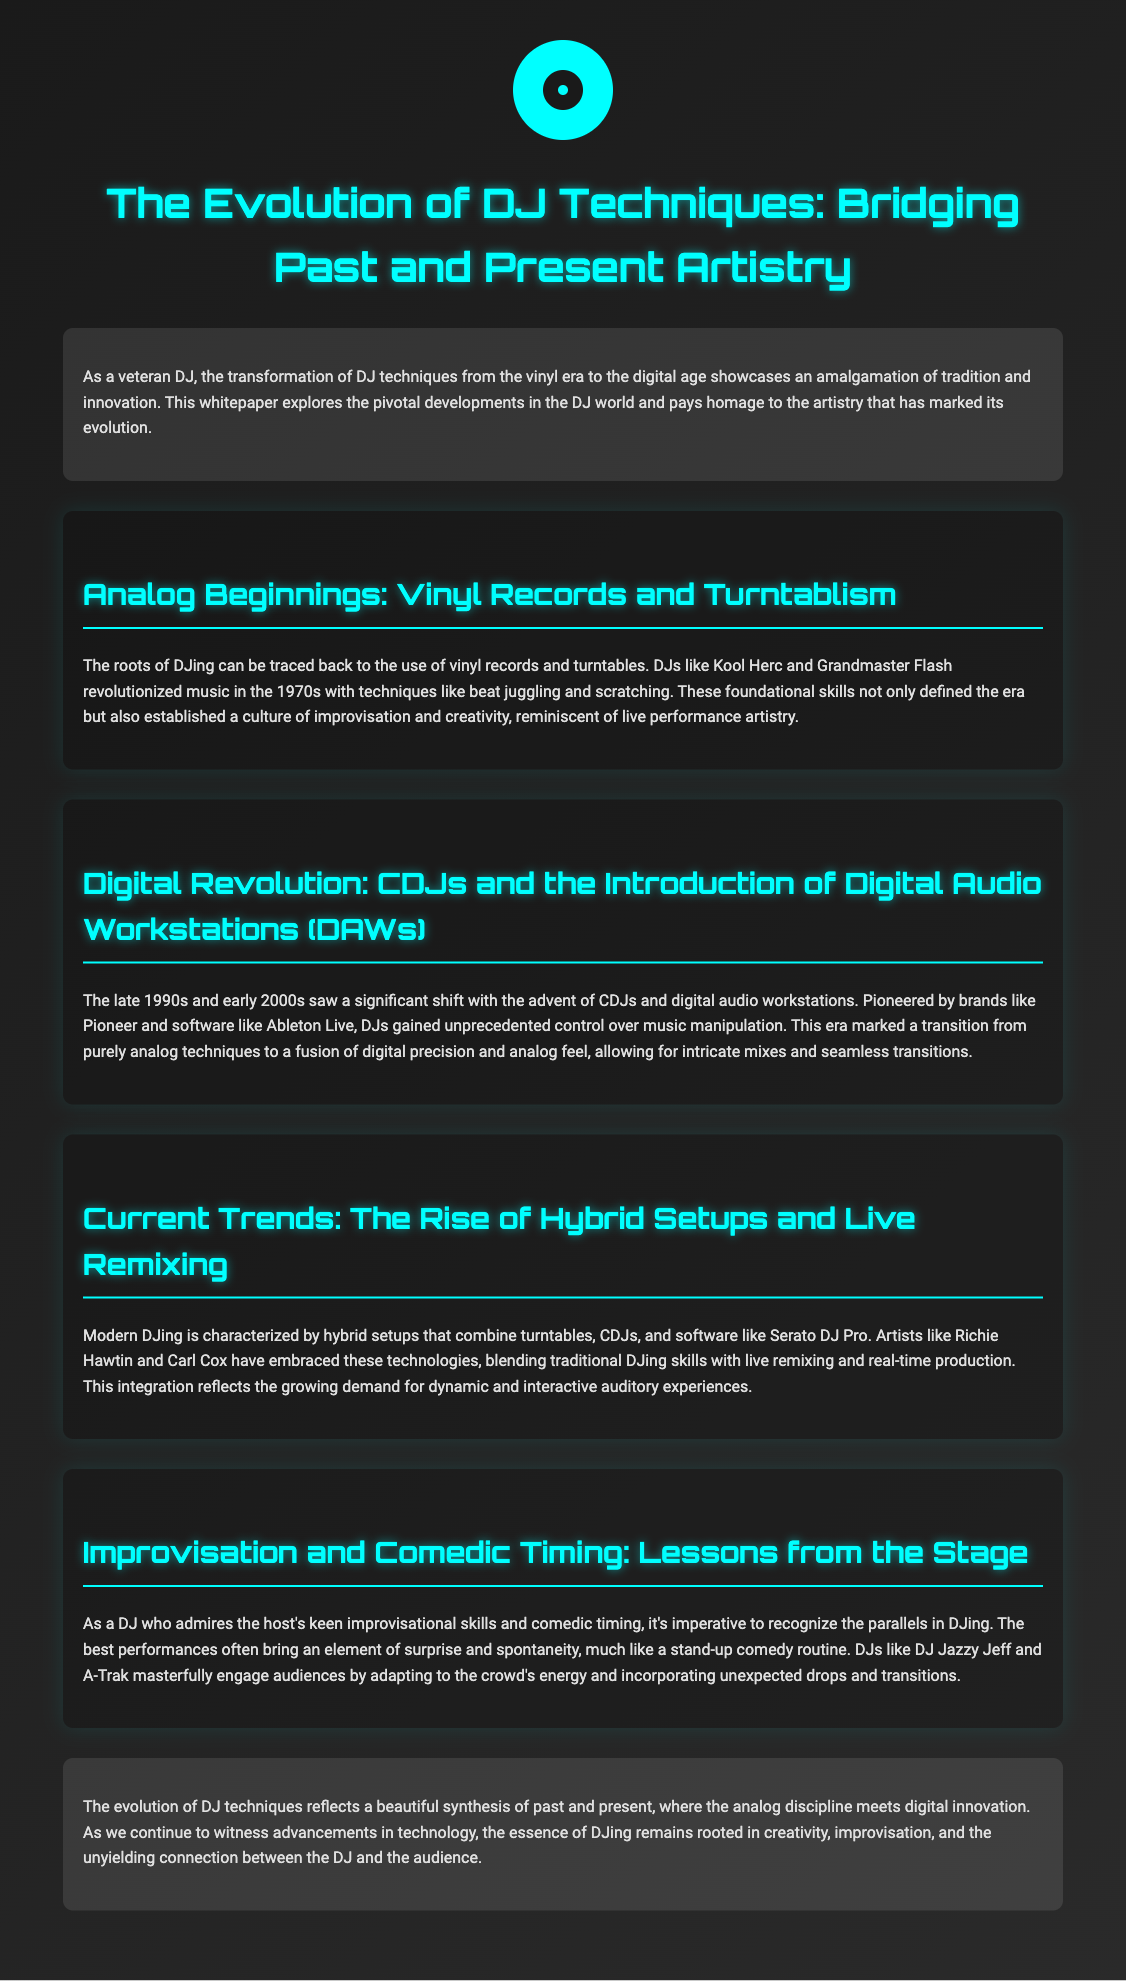What DJ techniques were revolutionized in the 1970s? The document mentions that Kool Herc and Grandmaster Flash revolutionized music with techniques like beat juggling and scratching.
Answer: Beat juggling and scratching What technology marked the transition to digital DJing? According to the document, the advent of CDJs and digital audio workstations marked a significant shift.
Answer: CDJs and digital audio workstations Who are two artists known for embracing modern DJ technologies? The document identifies Richie Hawtin and Carl Cox as artists who have embraced hybrid setups.
Answer: Richie Hawtin and Carl Cox What parallels are drawn between DJing and another performance art? The text suggests that there are parallels between DJ performances and stand-up comedy, particularly in terms of improvisation and engagement.
Answer: Stand-up comedy How does the document describe the essence of DJing? The conclusion states that the essence of DJing remains rooted in creativity, improvisation, and audience connection.
Answer: Creativity, improvisation, and audience connection In what era did the use of vinyl records become prominent? The document states that the roots of DJing can be traced back to the vinyl era.
Answer: Vinyl era What is one skill that defines modern DJing according to the document? The document mentions live remixing as a key characteristic of current DJing trends.
Answer: Live remixing What concept does the document acknowledge as significant to audience engagement? The text emphasizes the importance of surprise and spontaneity in engaging audiences during performances.
Answer: Surprise and spontaneity What was a key technological progression for DJs in the late 1990s and early 2000s? The document highlights the introduction of digital audio workstations as a key technological progression.
Answer: Digital audio workstations 